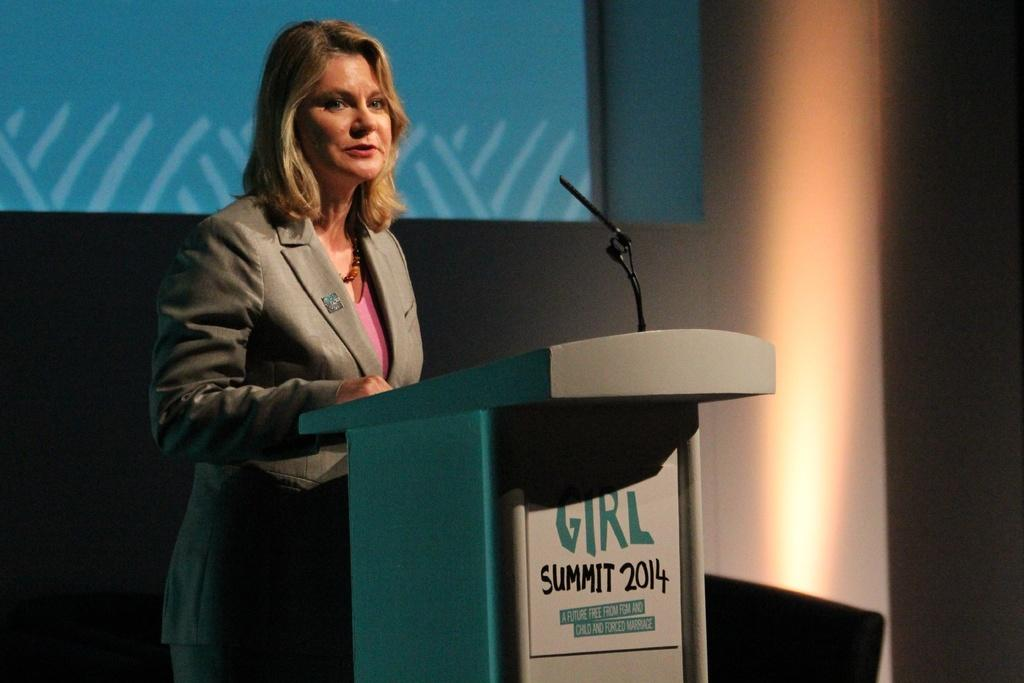Who is the main subject in the center of the picture? There is a woman in the center of the picture. What is the woman doing in front of the podium? The woman is standing in front of a podium and talking into a microphone. What is visible behind the woman? There is a projector screen behind the woman. What color is the wall on the right side of the image? The wall on the right side of the image is painted white. What shape is the cellar in the image? There is no cellar present in the image. How many ears can be seen on the woman in the image? The image only shows the woman from the front, so only one ear is visible. 